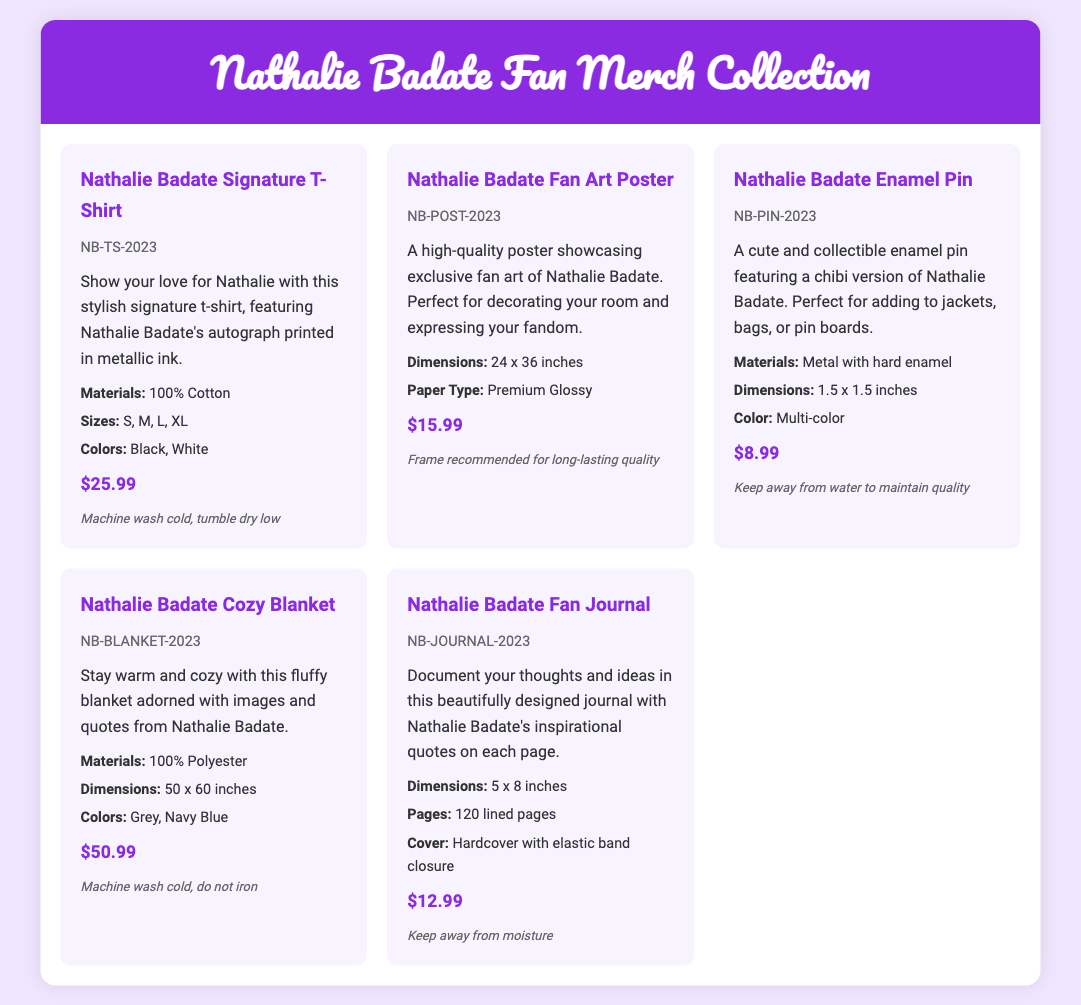what is the price of the Nathalie Badate Signature T-Shirt? The price is listed under the product's pricing details in the document.
Answer: $25.99 what materials are used for the Nathalie Badate Cozy Blanket? The materials are specifically mentioned in the product details section of the blanket.
Answer: 100% Polyester how many pages does the Nathalie Badate Fan Journal have? The number of pages is stated in the product details for the journal.
Answer: 120 lined pages what are the available colors for the Nathalie Badate Enamel Pin? The available colors are listed in the product details section for that item.
Answer: Multi-color which product has the code NB-POST-2023? The code for each product is unique and mentioned in the document.
Answer: Nathalie Badate Fan Art Poster which item features Nathalie Badate's autograph? The specific item description indicates what is included with each product.
Answer: Nathalie Badate Signature T-Shirt what is the dimension of the Nathalie Badate Fan Art Poster? The dimensions are provided in the product details section of the poster.
Answer: 24 x 36 inches what is the care instruction for the Nathalie Badate Cozy Blanket? The care instructions provide guidance for maintaining product quality.
Answer: Machine wash cold, do not iron 